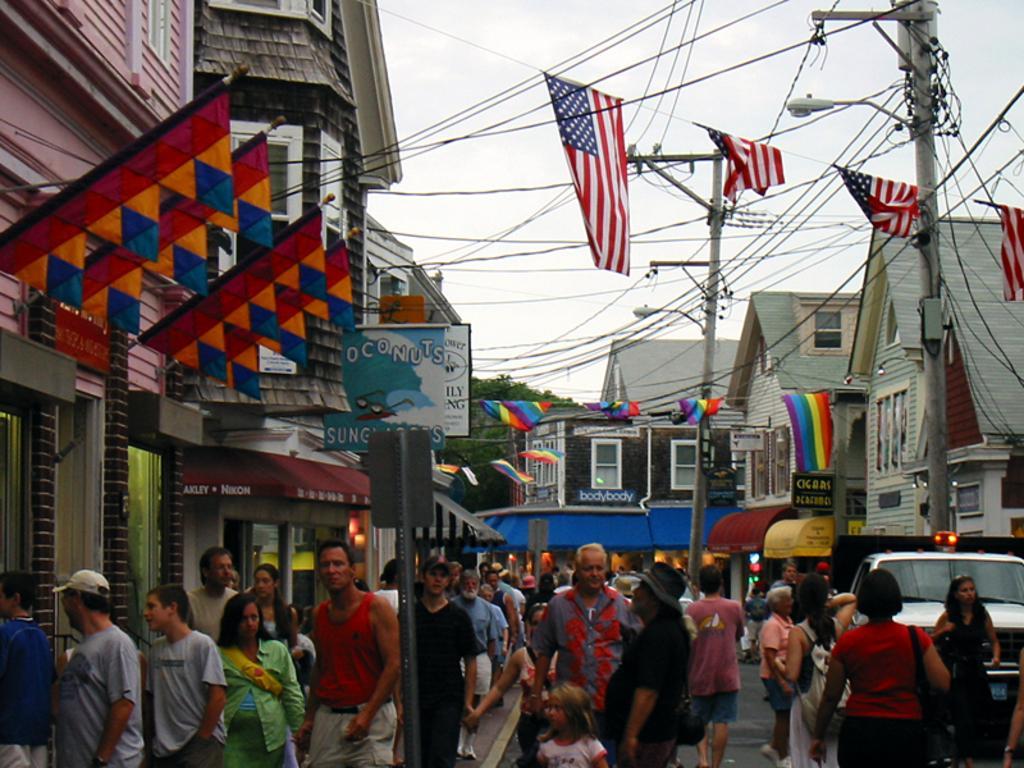Could you give a brief overview of what you see in this image? This picture is clicked outside. In the foreground we can see the group of people walking on the ground and we can see the flags, boards, poles, street lights, cables and some vehicles. In the background we can see the sky and the buildings and the trees. 